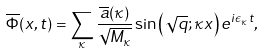<formula> <loc_0><loc_0><loc_500><loc_500>\overline { \Phi } ( x , t ) = \sum _ { \kappa } \frac { \overline { a } ( \kappa ) } { \sqrt { M _ { \kappa } } } \sin \left ( \sqrt { q } ; \kappa x \right ) e ^ { i \epsilon _ { \kappa } t } ,</formula> 